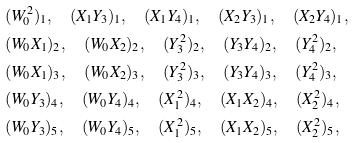<formula> <loc_0><loc_0><loc_500><loc_500>& ( W _ { 0 } ^ { 2 } ) _ { 1 } , \quad ( X _ { 1 } Y _ { 3 } ) _ { 1 } , \quad ( X _ { 1 } Y _ { 4 } ) _ { 1 } , \quad ( X _ { 2 } Y _ { 3 } ) _ { 1 } , \quad ( X _ { 2 } Y _ { 4 } ) _ { 1 } , & \\ & ( W _ { 0 } X _ { 1 } ) _ { 2 } , \quad ( W _ { 0 } X _ { 2 } ) _ { 2 } , \quad ( Y _ { 3 } ^ { 2 } ) _ { 2 } , \quad ( Y _ { 3 } Y _ { 4 } ) _ { 2 } , \quad ( Y _ { 4 } ^ { 2 } ) _ { 2 } , & \\ & ( W _ { 0 } X _ { 1 } ) _ { 3 } , \quad ( W _ { 0 } X _ { 2 } ) _ { 3 } , \quad ( Y _ { 3 } ^ { 2 } ) _ { 3 } , \quad ( Y _ { 3 } Y _ { 4 } ) _ { 3 } , \quad ( Y _ { 4 } ^ { 2 } ) _ { 3 } , & \\ & ( W _ { 0 } Y _ { 3 } ) _ { 4 } , \quad ( W _ { 0 } Y _ { 4 } ) _ { 4 } , \quad ( X _ { 1 } ^ { 2 } ) _ { 4 } , \quad ( X _ { 1 } X _ { 2 } ) _ { 4 } , \quad ( X _ { 2 } ^ { 2 } ) _ { 4 } , & \\ & ( W _ { 0 } Y _ { 3 } ) _ { 5 } , \quad ( W _ { 0 } Y _ { 4 } ) _ { 5 } , \quad ( X _ { 1 } ^ { 2 } ) _ { 5 } , \quad ( X _ { 1 } X _ { 2 } ) _ { 5 } , \quad ( X _ { 2 } ^ { 2 } ) _ { 5 } , &</formula> 